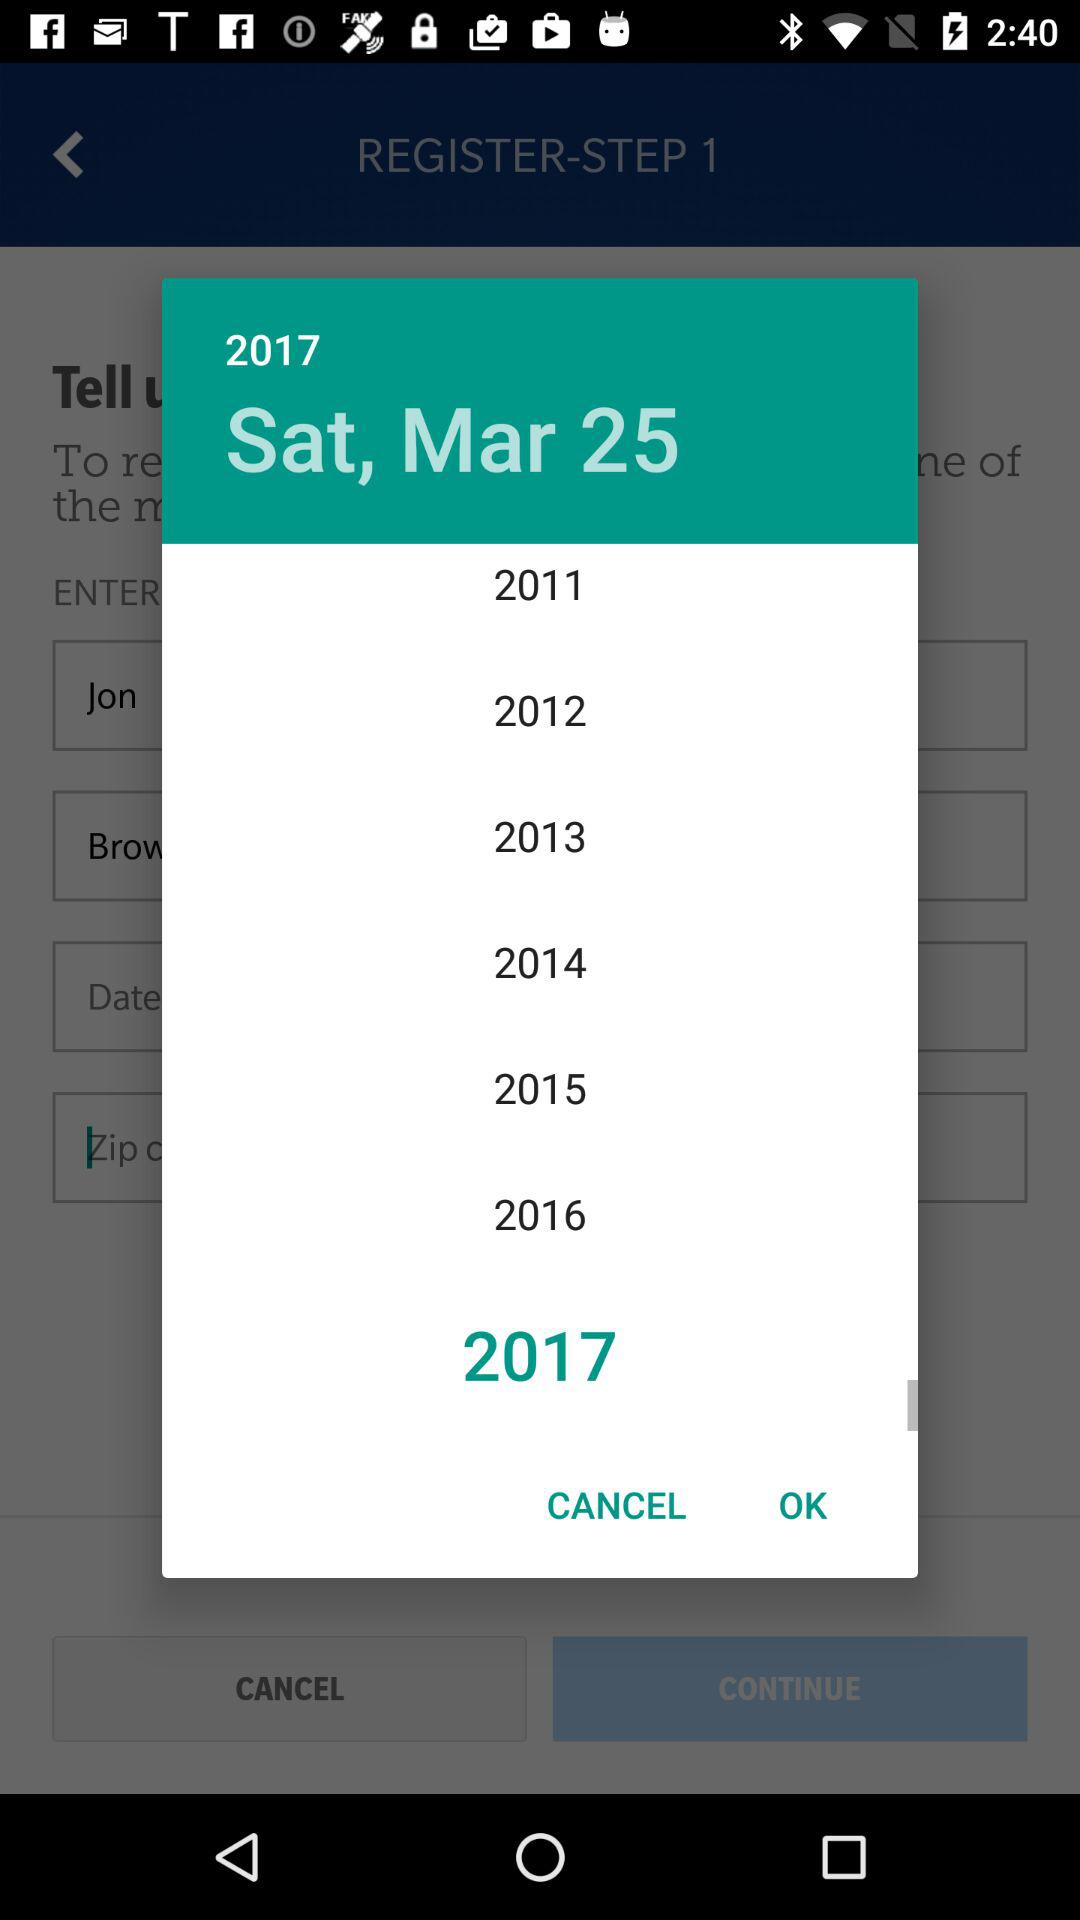How many years are available to select from?
Answer the question using a single word or phrase. 7 